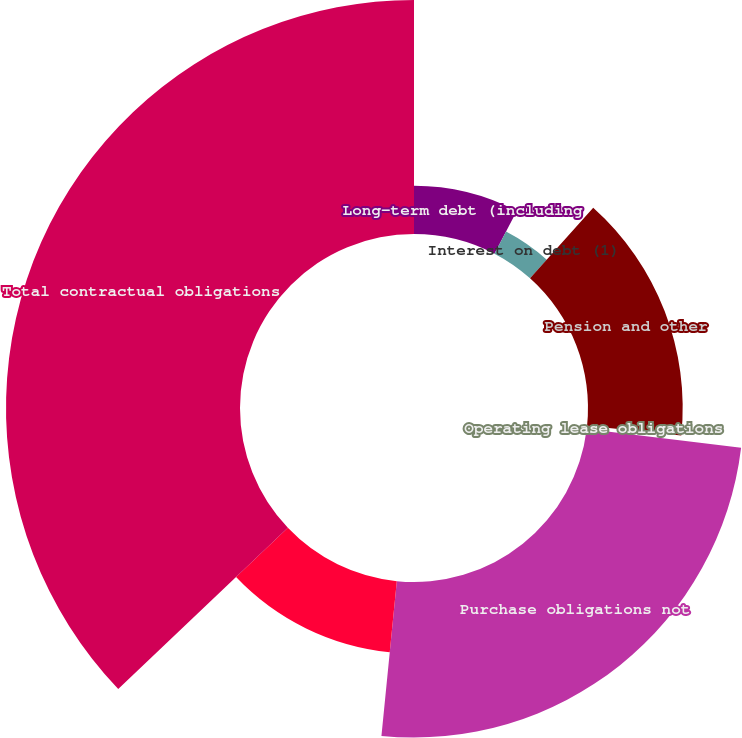Convert chart. <chart><loc_0><loc_0><loc_500><loc_500><pie_chart><fcel>Long-term debt (including<fcel>Interest on debt (1)<fcel>Pension and other<fcel>Operating lease obligations<fcel>Purchase obligations not<fcel>Purchase obligations recorded<fcel>Total contractual obligations<nl><fcel>7.65%<fcel>3.97%<fcel>15.01%<fcel>0.29%<fcel>24.65%<fcel>11.33%<fcel>37.09%<nl></chart> 